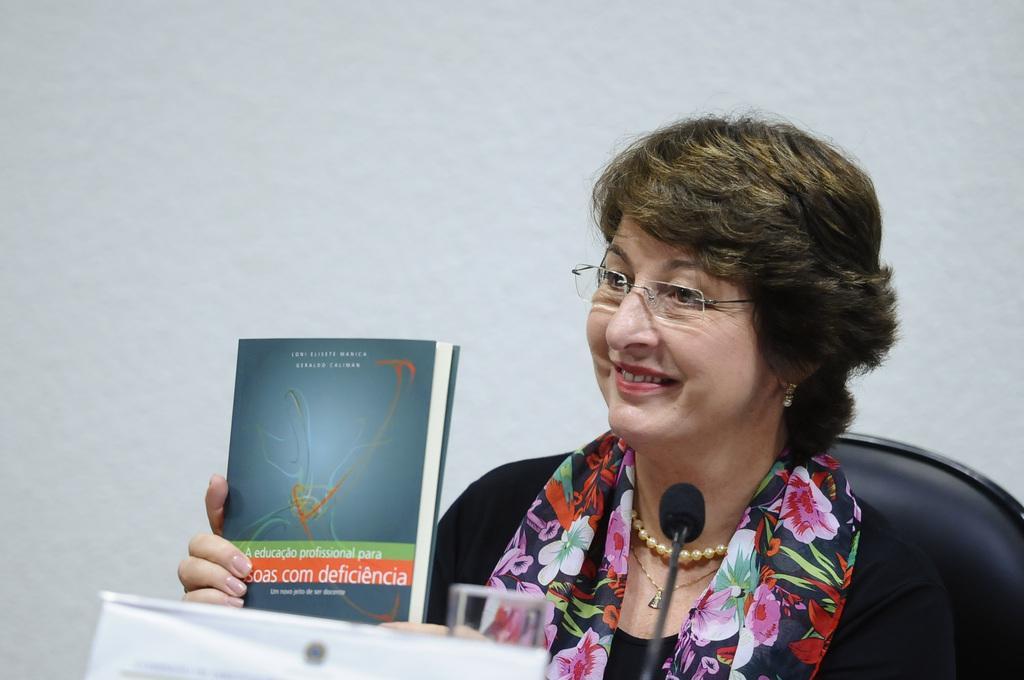Describe this image in one or two sentences. In the foreground of this image, there is a mic and a paper like an object. In the background, there is a woman in black dress sitting on the chair holding a book in her and also having smile on her face. In the background, there is a white wall. 